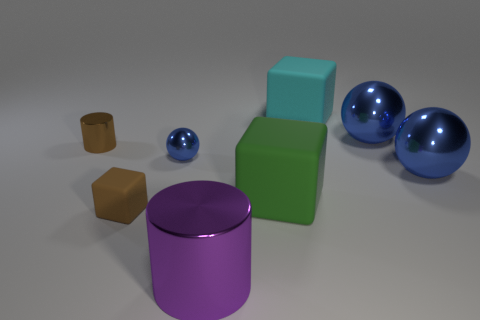Add 2 big brown rubber balls. How many objects exist? 10 Subtract all blocks. How many objects are left? 5 Subtract all green cubes. Subtract all large cyan rubber cubes. How many objects are left? 6 Add 6 tiny blue balls. How many tiny blue balls are left? 7 Add 1 large cyan rubber blocks. How many large cyan rubber blocks exist? 2 Subtract 1 cyan blocks. How many objects are left? 7 